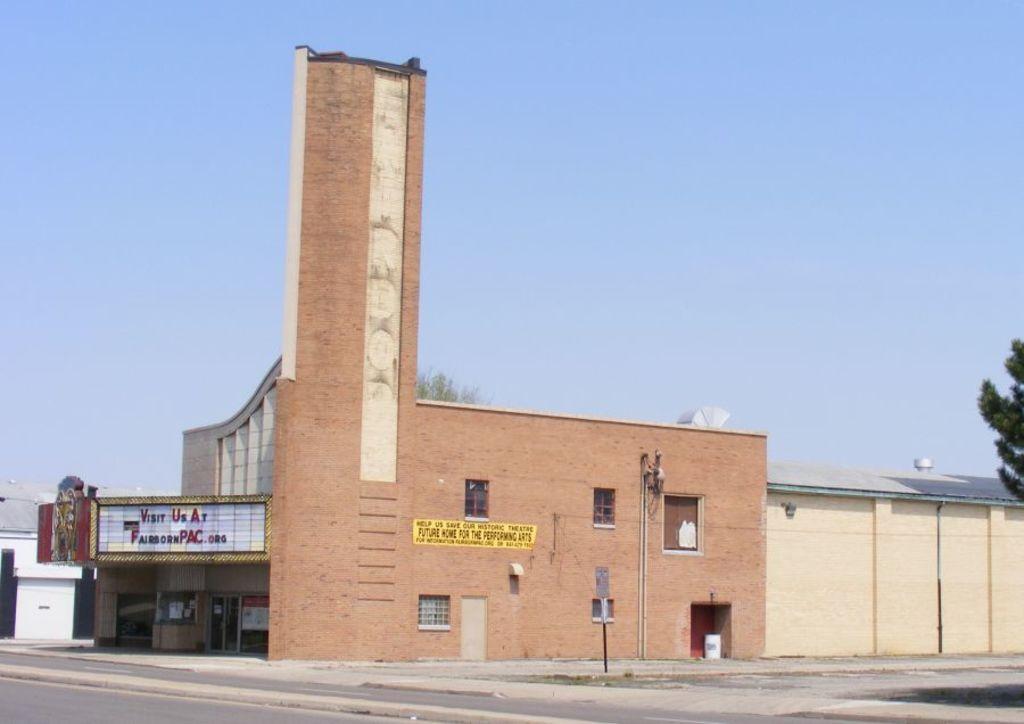How would you summarize this image in a sentence or two? In this picture there is a building which has something written on it and there is an object above it and there is a tree in the right corner and there is another building beside it. 